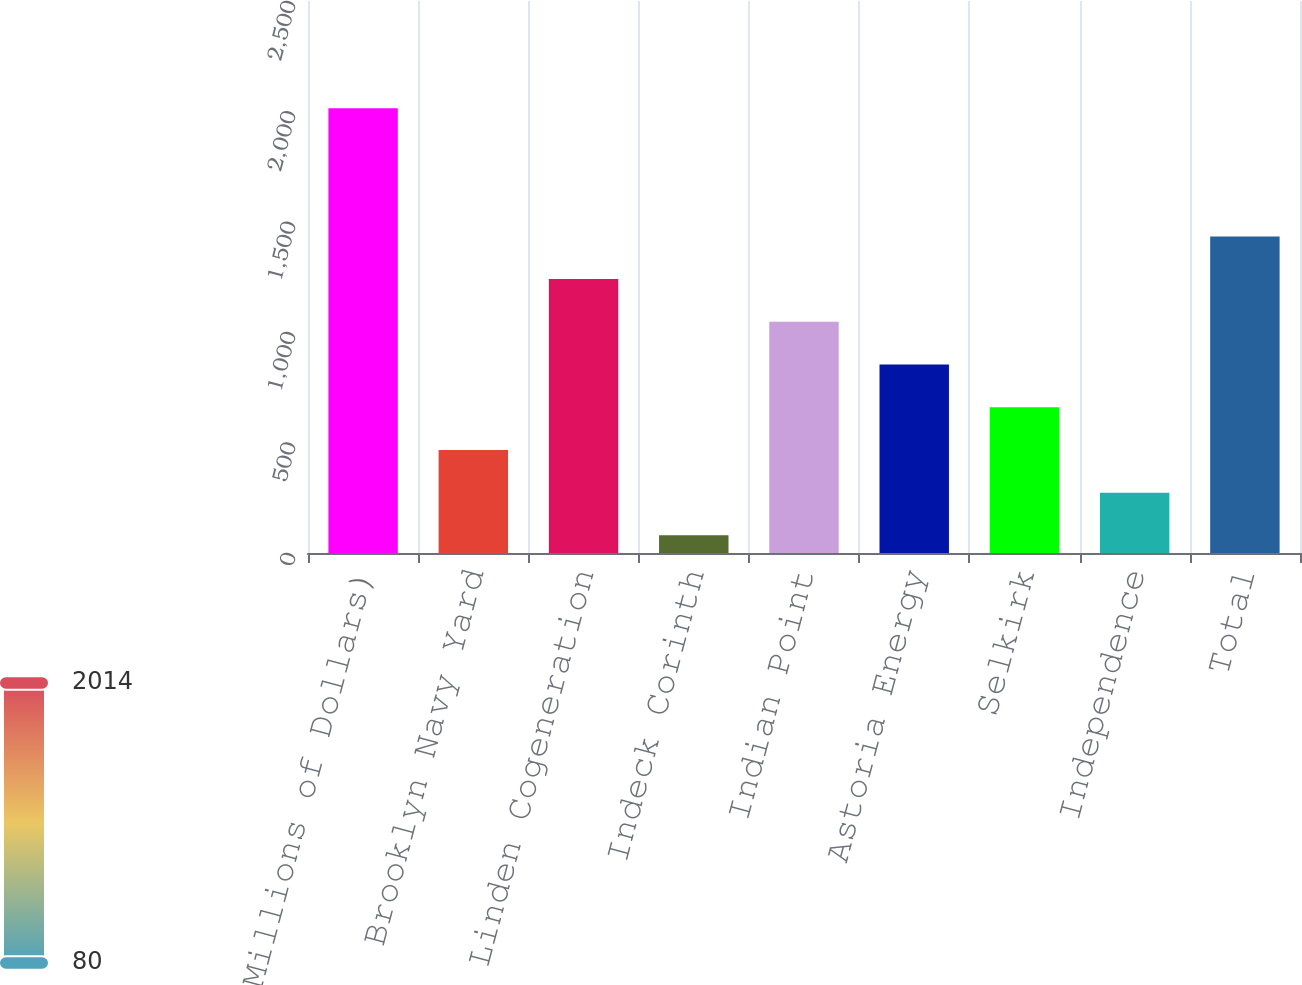Convert chart. <chart><loc_0><loc_0><loc_500><loc_500><bar_chart><fcel>(Millions of Dollars)<fcel>Brooklyn Navy Yard<fcel>Linden Cogeneration<fcel>Indeck Corinth<fcel>Indian Point<fcel>Astoria Energy<fcel>Selkirk<fcel>Independence<fcel>Total<nl><fcel>2014<fcel>466.8<fcel>1240.4<fcel>80<fcel>1047<fcel>853.6<fcel>660.2<fcel>273.4<fcel>1433.8<nl></chart> 